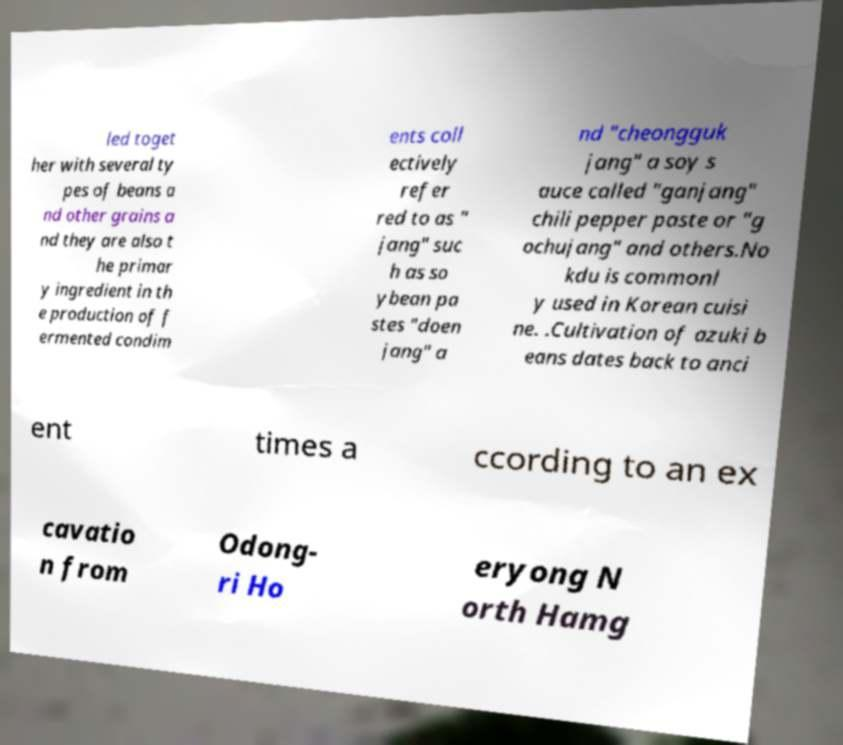What messages or text are displayed in this image? I need them in a readable, typed format. led toget her with several ty pes of beans a nd other grains a nd they are also t he primar y ingredient in th e production of f ermented condim ents coll ectively refer red to as " jang" suc h as so ybean pa stes "doen jang" a nd "cheongguk jang" a soy s auce called "ganjang" chili pepper paste or "g ochujang" and others.No kdu is commonl y used in Korean cuisi ne. .Cultivation of azuki b eans dates back to anci ent times a ccording to an ex cavatio n from Odong- ri Ho eryong N orth Hamg 